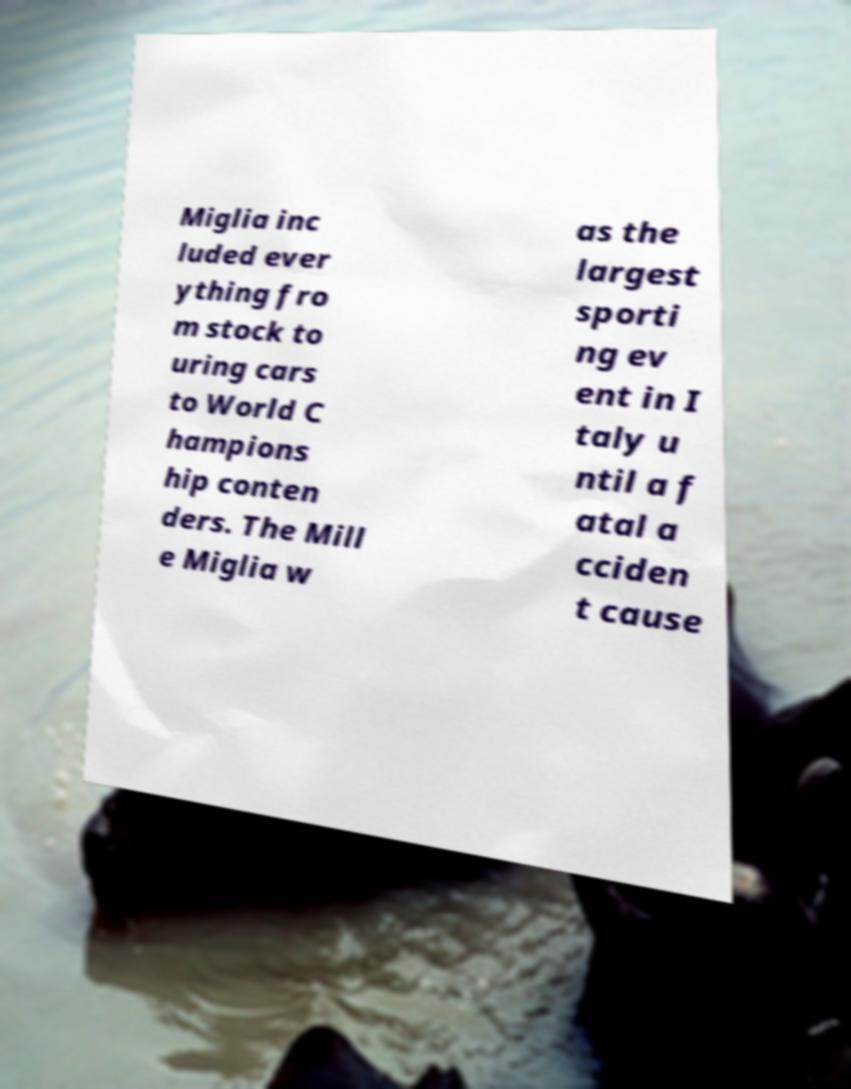For documentation purposes, I need the text within this image transcribed. Could you provide that? Miglia inc luded ever ything fro m stock to uring cars to World C hampions hip conten ders. The Mill e Miglia w as the largest sporti ng ev ent in I taly u ntil a f atal a cciden t cause 